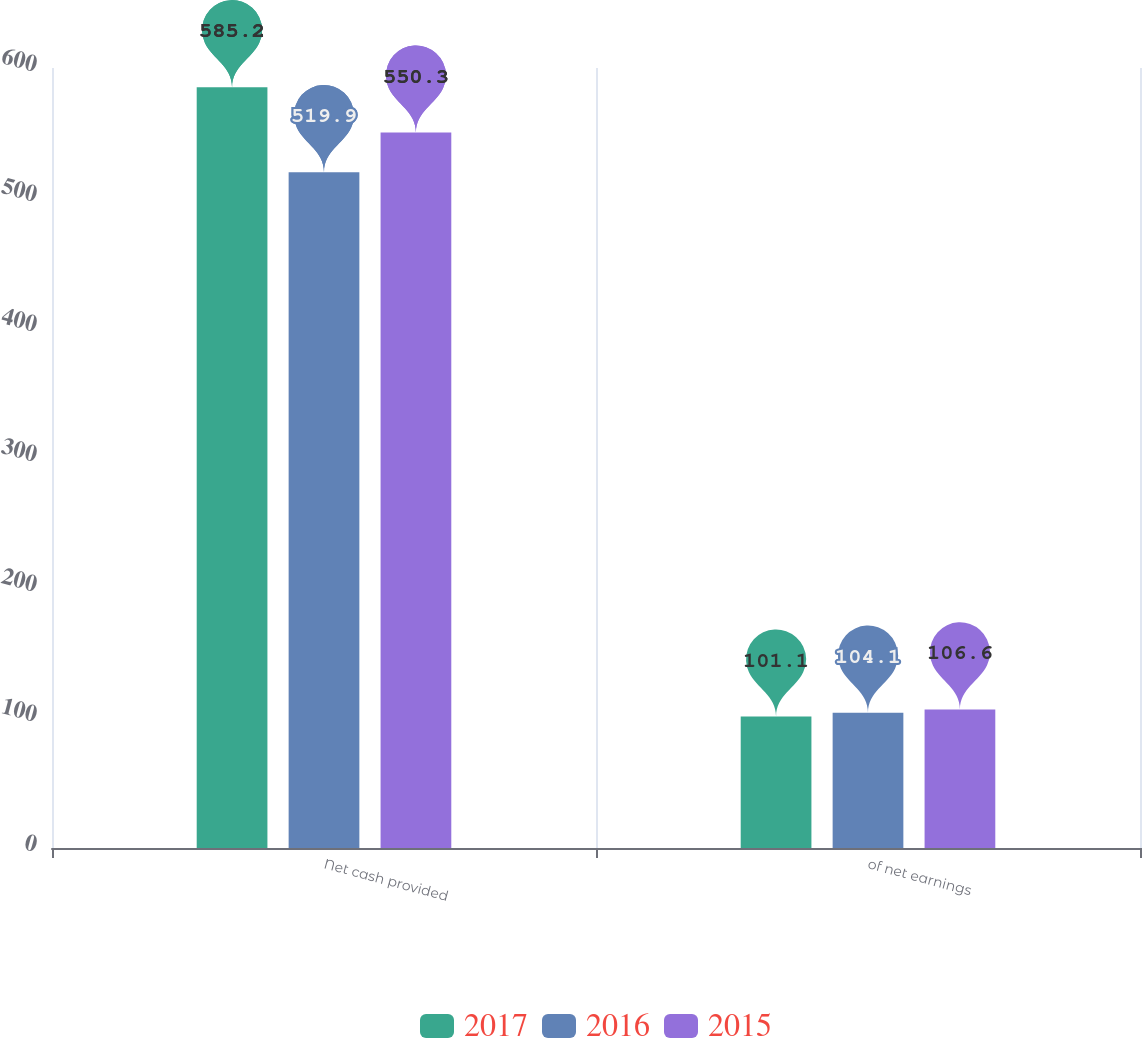<chart> <loc_0><loc_0><loc_500><loc_500><stacked_bar_chart><ecel><fcel>Net cash provided<fcel>of net earnings<nl><fcel>2017<fcel>585.2<fcel>101.1<nl><fcel>2016<fcel>519.9<fcel>104.1<nl><fcel>2015<fcel>550.3<fcel>106.6<nl></chart> 